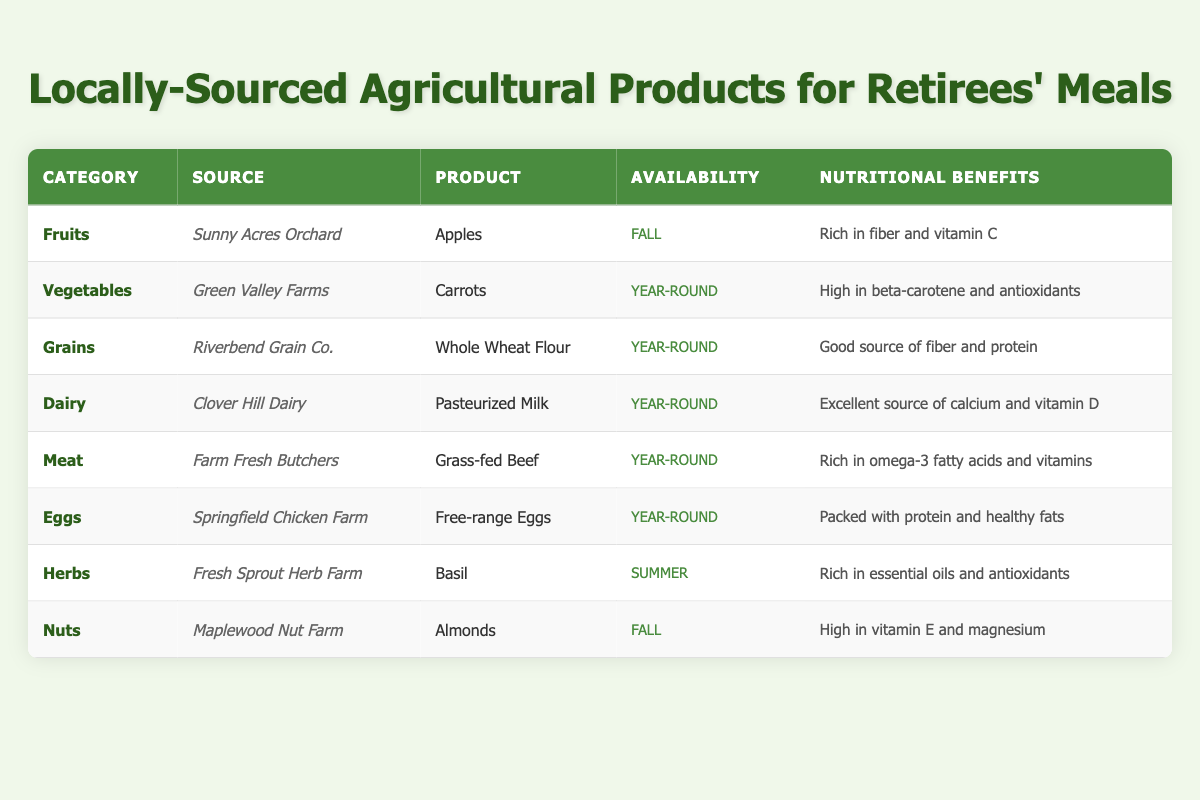What are the nutritional benefits of free-range eggs? The table indicates that free-range eggs have nutritional benefits as they are "packed with protein and healthy fats."
Answer: Packed with protein and healthy fats Which product is available year-round and comes from Riverbend Grain Co.? The table lists "Whole Wheat Flour" as the product from Riverbend Grain Co. with availability marked as "Year-round."
Answer: Whole Wheat Flour Are almonds available in the summer? The table states that almonds, sourced from Maplewood Nut Farm, are available in the "Fall." Therefore, the statement is false.
Answer: No What is the source of grass-fed beef? According to the table, the source of grass-fed beef is "Farm Fresh Butchers."
Answer: Farm Fresh Butchers How many categories of products are available year-round? By counting the rows where the availability is "Year-round," we find there are 5 categories: Vegetables, Grains, Dairy, Meat, and Eggs. Adding these up, we get 5.
Answer: 5 Are there any products available only in the fall? The products listed under "availability" show that both apples and almonds are available only in the fall. Therefore, the answer is true.
Answer: Yes What are the two sources providing products in the fall? The table shows that "Sunny Acres Orchard" provides apples and "Maplewood Nut Farm" provides almonds during the fall. Thus, the sources are Sunny Acres Orchard and Maplewood Nut Farm.
Answer: Sunny Acres Orchard and Maplewood Nut Farm Which category has the product that is rich in beta-carotene? The table indicates that carrots fall under the "Vegetables" category and are described as "high in beta-carotene and antioxidants."
Answer: Vegetables 